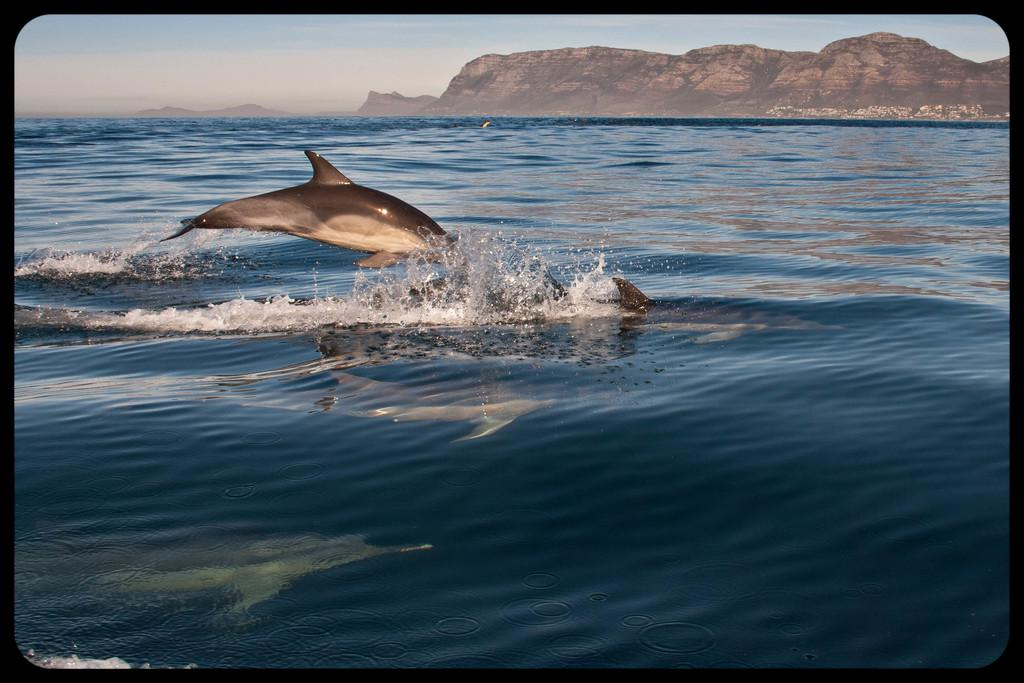What animals are present in the image? There are dolphins in the image. What is one of the dolphins doing in the image? A dolphin is jumping into the water. What can be seen in the distance in the image? There are mountains in the background of the image. What else is visible in the background of the image? The sky is visible in the background of the image. What type of comb is being used by the dolphin in the image? There is no comb present in the image; it features dolphins in the water with mountains and sky in the background. 